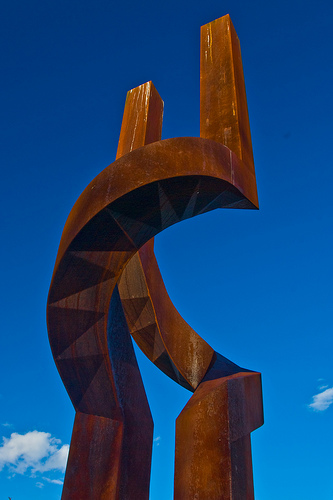<image>
Can you confirm if the left arch is to the right of the right arch? Yes. From this viewpoint, the left arch is positioned to the right side relative to the right arch. 